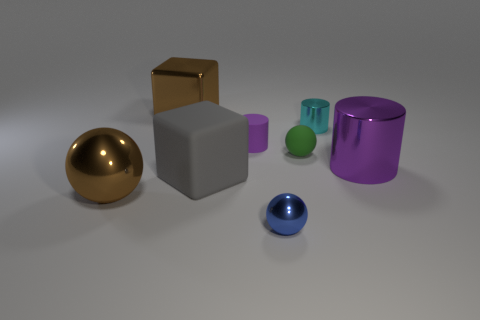Subtract all small cylinders. How many cylinders are left? 1 Subtract all gray blocks. How many purple cylinders are left? 2 Subtract 1 balls. How many balls are left? 2 Add 2 big metal things. How many objects exist? 10 Subtract all brown spheres. How many spheres are left? 2 Subtract all cylinders. How many objects are left? 5 Subtract all purple balls. Subtract all yellow cubes. How many balls are left? 3 Subtract all tiny yellow matte things. Subtract all tiny green things. How many objects are left? 7 Add 2 small cyan objects. How many small cyan objects are left? 3 Add 4 gray metal objects. How many gray metal objects exist? 4 